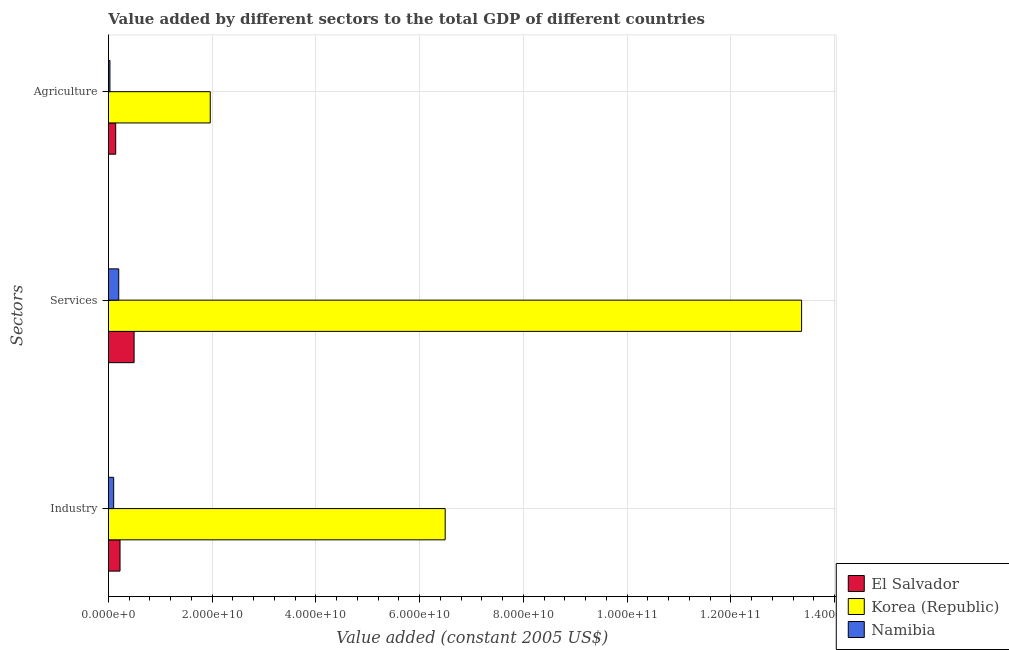How many groups of bars are there?
Provide a short and direct response. 3. Are the number of bars per tick equal to the number of legend labels?
Offer a terse response. Yes. What is the label of the 1st group of bars from the top?
Keep it short and to the point. Agriculture. What is the value added by services in Namibia?
Offer a terse response. 1.99e+09. Across all countries, what is the maximum value added by industrial sector?
Provide a succinct answer. 6.49e+1. Across all countries, what is the minimum value added by industrial sector?
Offer a very short reply. 1.01e+09. In which country was the value added by agricultural sector maximum?
Provide a short and direct response. Korea (Republic). In which country was the value added by industrial sector minimum?
Offer a very short reply. Namibia. What is the total value added by agricultural sector in the graph?
Provide a succinct answer. 2.13e+1. What is the difference between the value added by agricultural sector in El Salvador and that in Korea (Republic)?
Give a very brief answer. -1.82e+1. What is the difference between the value added by industrial sector in Korea (Republic) and the value added by services in El Salvador?
Your response must be concise. 6.00e+1. What is the average value added by agricultural sector per country?
Provide a succinct answer. 7.11e+09. What is the difference between the value added by services and value added by industrial sector in El Salvador?
Keep it short and to the point. 2.71e+09. In how many countries, is the value added by agricultural sector greater than 12000000000 US$?
Provide a short and direct response. 1. What is the ratio of the value added by agricultural sector in El Salvador to that in Namibia?
Your response must be concise. 4.87. Is the value added by agricultural sector in Namibia less than that in Korea (Republic)?
Your response must be concise. Yes. What is the difference between the highest and the second highest value added by services?
Provide a short and direct response. 1.29e+11. What is the difference between the highest and the lowest value added by services?
Your answer should be compact. 1.32e+11. Is the sum of the value added by services in El Salvador and Korea (Republic) greater than the maximum value added by industrial sector across all countries?
Your answer should be very brief. Yes. What does the 2nd bar from the top in Industry represents?
Ensure brevity in your answer.  Korea (Republic). What does the 2nd bar from the bottom in Industry represents?
Your answer should be compact. Korea (Republic). How many bars are there?
Offer a terse response. 9. Are all the bars in the graph horizontal?
Your answer should be very brief. Yes. What is the difference between two consecutive major ticks on the X-axis?
Your answer should be very brief. 2.00e+1. Are the values on the major ticks of X-axis written in scientific E-notation?
Offer a terse response. Yes. Does the graph contain grids?
Provide a short and direct response. Yes. Where does the legend appear in the graph?
Make the answer very short. Bottom right. How many legend labels are there?
Give a very brief answer. 3. How are the legend labels stacked?
Your response must be concise. Vertical. What is the title of the graph?
Offer a terse response. Value added by different sectors to the total GDP of different countries. Does "Bermuda" appear as one of the legend labels in the graph?
Offer a very short reply. No. What is the label or title of the X-axis?
Ensure brevity in your answer.  Value added (constant 2005 US$). What is the label or title of the Y-axis?
Provide a succinct answer. Sectors. What is the Value added (constant 2005 US$) of El Salvador in Industry?
Make the answer very short. 2.24e+09. What is the Value added (constant 2005 US$) of Korea (Republic) in Industry?
Make the answer very short. 6.49e+1. What is the Value added (constant 2005 US$) in Namibia in Industry?
Give a very brief answer. 1.01e+09. What is the Value added (constant 2005 US$) of El Salvador in Services?
Make the answer very short. 4.95e+09. What is the Value added (constant 2005 US$) of Korea (Republic) in Services?
Your response must be concise. 1.34e+11. What is the Value added (constant 2005 US$) in Namibia in Services?
Your answer should be compact. 1.99e+09. What is the Value added (constant 2005 US$) in El Salvador in Agriculture?
Provide a succinct answer. 1.40e+09. What is the Value added (constant 2005 US$) of Korea (Republic) in Agriculture?
Offer a very short reply. 1.96e+1. What is the Value added (constant 2005 US$) of Namibia in Agriculture?
Provide a short and direct response. 2.88e+08. Across all Sectors, what is the maximum Value added (constant 2005 US$) in El Salvador?
Provide a succinct answer. 4.95e+09. Across all Sectors, what is the maximum Value added (constant 2005 US$) in Korea (Republic)?
Ensure brevity in your answer.  1.34e+11. Across all Sectors, what is the maximum Value added (constant 2005 US$) of Namibia?
Ensure brevity in your answer.  1.99e+09. Across all Sectors, what is the minimum Value added (constant 2005 US$) in El Salvador?
Provide a succinct answer. 1.40e+09. Across all Sectors, what is the minimum Value added (constant 2005 US$) in Korea (Republic)?
Make the answer very short. 1.96e+1. Across all Sectors, what is the minimum Value added (constant 2005 US$) in Namibia?
Offer a very short reply. 2.88e+08. What is the total Value added (constant 2005 US$) of El Salvador in the graph?
Your response must be concise. 8.59e+09. What is the total Value added (constant 2005 US$) of Korea (Republic) in the graph?
Ensure brevity in your answer.  2.18e+11. What is the total Value added (constant 2005 US$) in Namibia in the graph?
Make the answer very short. 3.28e+09. What is the difference between the Value added (constant 2005 US$) of El Salvador in Industry and that in Services?
Your answer should be compact. -2.71e+09. What is the difference between the Value added (constant 2005 US$) of Korea (Republic) in Industry and that in Services?
Offer a very short reply. -6.87e+1. What is the difference between the Value added (constant 2005 US$) in Namibia in Industry and that in Services?
Keep it short and to the point. -9.77e+08. What is the difference between the Value added (constant 2005 US$) in El Salvador in Industry and that in Agriculture?
Your answer should be very brief. 8.35e+08. What is the difference between the Value added (constant 2005 US$) of Korea (Republic) in Industry and that in Agriculture?
Give a very brief answer. 4.53e+1. What is the difference between the Value added (constant 2005 US$) of Namibia in Industry and that in Agriculture?
Provide a short and direct response. 7.23e+08. What is the difference between the Value added (constant 2005 US$) of El Salvador in Services and that in Agriculture?
Your response must be concise. 3.55e+09. What is the difference between the Value added (constant 2005 US$) in Korea (Republic) in Services and that in Agriculture?
Your response must be concise. 1.14e+11. What is the difference between the Value added (constant 2005 US$) of Namibia in Services and that in Agriculture?
Offer a very short reply. 1.70e+09. What is the difference between the Value added (constant 2005 US$) of El Salvador in Industry and the Value added (constant 2005 US$) of Korea (Republic) in Services?
Offer a terse response. -1.31e+11. What is the difference between the Value added (constant 2005 US$) in El Salvador in Industry and the Value added (constant 2005 US$) in Namibia in Services?
Offer a very short reply. 2.49e+08. What is the difference between the Value added (constant 2005 US$) of Korea (Republic) in Industry and the Value added (constant 2005 US$) of Namibia in Services?
Offer a very short reply. 6.29e+1. What is the difference between the Value added (constant 2005 US$) in El Salvador in Industry and the Value added (constant 2005 US$) in Korea (Republic) in Agriculture?
Give a very brief answer. -1.74e+1. What is the difference between the Value added (constant 2005 US$) of El Salvador in Industry and the Value added (constant 2005 US$) of Namibia in Agriculture?
Your answer should be very brief. 1.95e+09. What is the difference between the Value added (constant 2005 US$) in Korea (Republic) in Industry and the Value added (constant 2005 US$) in Namibia in Agriculture?
Give a very brief answer. 6.46e+1. What is the difference between the Value added (constant 2005 US$) of El Salvador in Services and the Value added (constant 2005 US$) of Korea (Republic) in Agriculture?
Keep it short and to the point. -1.47e+1. What is the difference between the Value added (constant 2005 US$) of El Salvador in Services and the Value added (constant 2005 US$) of Namibia in Agriculture?
Keep it short and to the point. 4.66e+09. What is the difference between the Value added (constant 2005 US$) of Korea (Republic) in Services and the Value added (constant 2005 US$) of Namibia in Agriculture?
Give a very brief answer. 1.33e+11. What is the average Value added (constant 2005 US$) in El Salvador per Sectors?
Offer a terse response. 2.86e+09. What is the average Value added (constant 2005 US$) of Korea (Republic) per Sectors?
Your answer should be compact. 7.27e+1. What is the average Value added (constant 2005 US$) of Namibia per Sectors?
Offer a terse response. 1.09e+09. What is the difference between the Value added (constant 2005 US$) in El Salvador and Value added (constant 2005 US$) in Korea (Republic) in Industry?
Your answer should be very brief. -6.27e+1. What is the difference between the Value added (constant 2005 US$) of El Salvador and Value added (constant 2005 US$) of Namibia in Industry?
Provide a short and direct response. 1.23e+09. What is the difference between the Value added (constant 2005 US$) of Korea (Republic) and Value added (constant 2005 US$) of Namibia in Industry?
Offer a terse response. 6.39e+1. What is the difference between the Value added (constant 2005 US$) of El Salvador and Value added (constant 2005 US$) of Korea (Republic) in Services?
Give a very brief answer. -1.29e+11. What is the difference between the Value added (constant 2005 US$) in El Salvador and Value added (constant 2005 US$) in Namibia in Services?
Ensure brevity in your answer.  2.96e+09. What is the difference between the Value added (constant 2005 US$) in Korea (Republic) and Value added (constant 2005 US$) in Namibia in Services?
Your answer should be compact. 1.32e+11. What is the difference between the Value added (constant 2005 US$) of El Salvador and Value added (constant 2005 US$) of Korea (Republic) in Agriculture?
Provide a succinct answer. -1.82e+1. What is the difference between the Value added (constant 2005 US$) in El Salvador and Value added (constant 2005 US$) in Namibia in Agriculture?
Give a very brief answer. 1.11e+09. What is the difference between the Value added (constant 2005 US$) of Korea (Republic) and Value added (constant 2005 US$) of Namibia in Agriculture?
Your answer should be compact. 1.93e+1. What is the ratio of the Value added (constant 2005 US$) in El Salvador in Industry to that in Services?
Your answer should be compact. 0.45. What is the ratio of the Value added (constant 2005 US$) in Korea (Republic) in Industry to that in Services?
Provide a short and direct response. 0.49. What is the ratio of the Value added (constant 2005 US$) in Namibia in Industry to that in Services?
Provide a short and direct response. 0.51. What is the ratio of the Value added (constant 2005 US$) of El Salvador in Industry to that in Agriculture?
Provide a succinct answer. 1.6. What is the ratio of the Value added (constant 2005 US$) of Korea (Republic) in Industry to that in Agriculture?
Give a very brief answer. 3.31. What is the ratio of the Value added (constant 2005 US$) of Namibia in Industry to that in Agriculture?
Offer a terse response. 3.51. What is the ratio of the Value added (constant 2005 US$) in El Salvador in Services to that in Agriculture?
Offer a terse response. 3.53. What is the ratio of the Value added (constant 2005 US$) of Korea (Republic) in Services to that in Agriculture?
Keep it short and to the point. 6.81. What is the ratio of the Value added (constant 2005 US$) of Namibia in Services to that in Agriculture?
Provide a succinct answer. 6.91. What is the difference between the highest and the second highest Value added (constant 2005 US$) in El Salvador?
Provide a succinct answer. 2.71e+09. What is the difference between the highest and the second highest Value added (constant 2005 US$) of Korea (Republic)?
Your response must be concise. 6.87e+1. What is the difference between the highest and the second highest Value added (constant 2005 US$) in Namibia?
Make the answer very short. 9.77e+08. What is the difference between the highest and the lowest Value added (constant 2005 US$) of El Salvador?
Keep it short and to the point. 3.55e+09. What is the difference between the highest and the lowest Value added (constant 2005 US$) in Korea (Republic)?
Your response must be concise. 1.14e+11. What is the difference between the highest and the lowest Value added (constant 2005 US$) in Namibia?
Provide a short and direct response. 1.70e+09. 